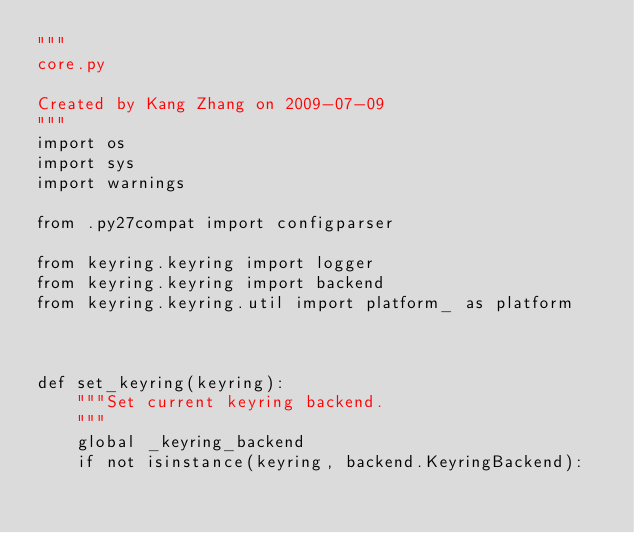<code> <loc_0><loc_0><loc_500><loc_500><_Python_>"""
core.py

Created by Kang Zhang on 2009-07-09
"""
import os
import sys
import warnings

from .py27compat import configparser

from keyring.keyring import logger
from keyring.keyring import backend
from keyring.keyring.util import platform_ as platform



def set_keyring(keyring):
    """Set current keyring backend.
    """
    global _keyring_backend
    if not isinstance(keyring, backend.KeyringBackend):</code> 